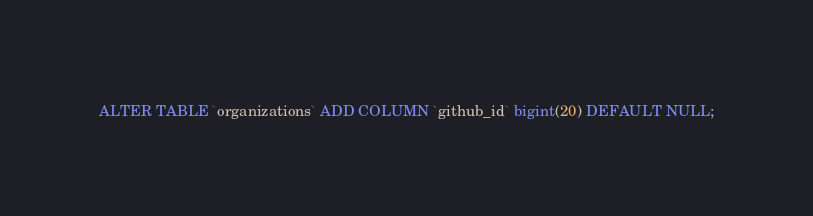<code> <loc_0><loc_0><loc_500><loc_500><_SQL_>ALTER TABLE `organizations` ADD COLUMN `github_id` bigint(20) DEFAULT NULL;
</code> 